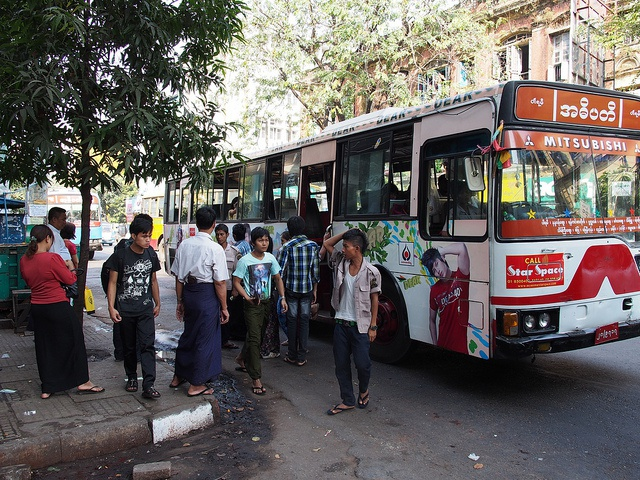Describe the objects in this image and their specific colors. I can see bus in black, darkgray, gray, and lightgray tones, people in black, lavender, navy, and darkgray tones, people in black, maroon, brown, and gray tones, people in black, darkgray, gray, and maroon tones, and people in black, gray, brown, and maroon tones in this image. 